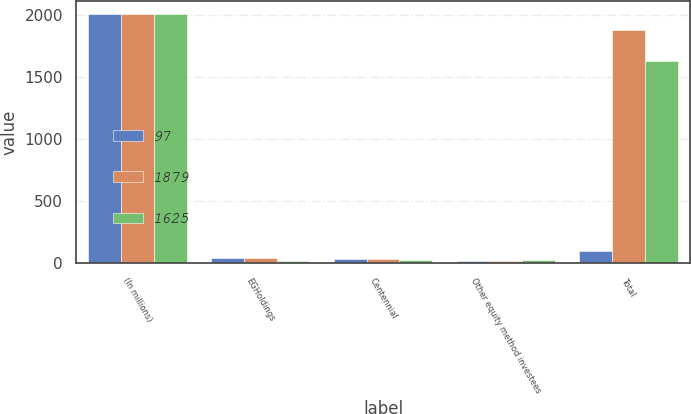<chart> <loc_0><loc_0><loc_500><loc_500><stacked_bar_chart><ecel><fcel>(In millions)<fcel>EGHoldings<fcel>Centennial<fcel>Other equity method investees<fcel>Total<nl><fcel>97<fcel>2009<fcel>44<fcel>34<fcel>19<fcel>97<nl><fcel>1879<fcel>2008<fcel>39<fcel>31<fcel>20<fcel>1879<nl><fcel>1625<fcel>2007<fcel>19<fcel>27<fcel>23<fcel>1625<nl></chart> 